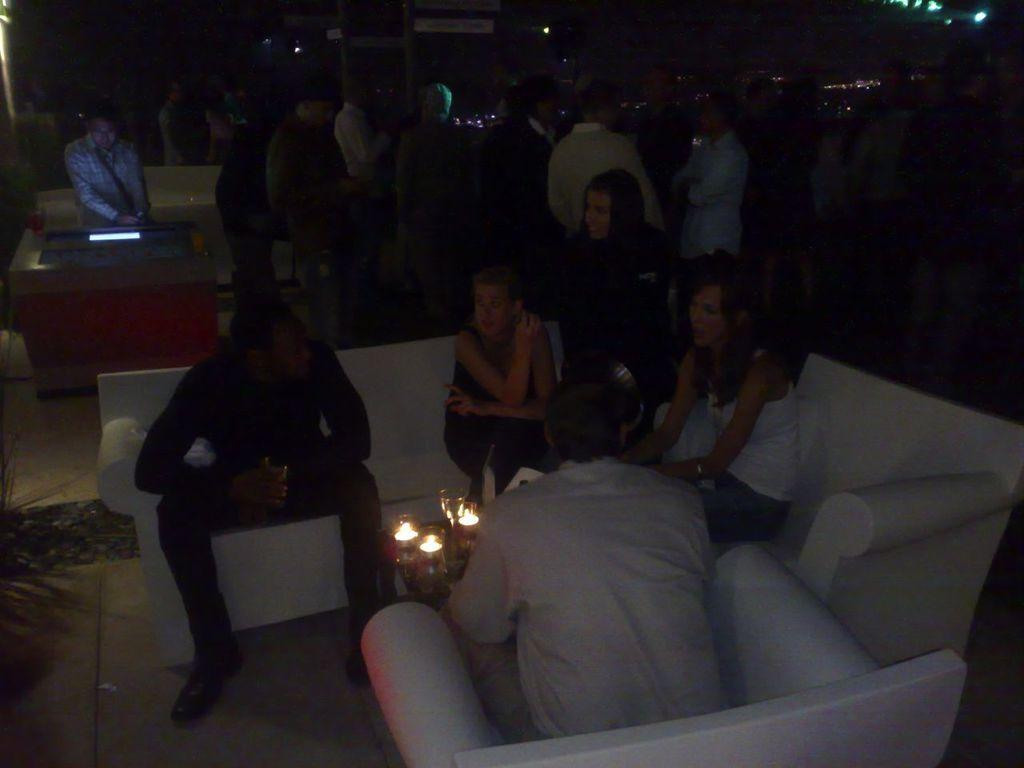What are the people in the image doing? The people in the image are sitting on sofas and standing on the floor. What type of objects can be seen in the image that provide light? Lights are visible in the image. What type of furniture is present in the image? Tables are present in the image. What type of objects can be seen in the image that are used for decoration or ambiance? Candles are visible in the image. What type of objects can be seen in the image that are used for support or structure? Poles are present in the image. What type of objects can be seen in the image that are used for display or communication? Boards are present in the image. What other objects can be seen in the image? Other objects are present in the image. What time does the clock show in the image? There is no clock present in the image. What type of plants can be seen in the image? There is no mention of plants or bushes in the image. 